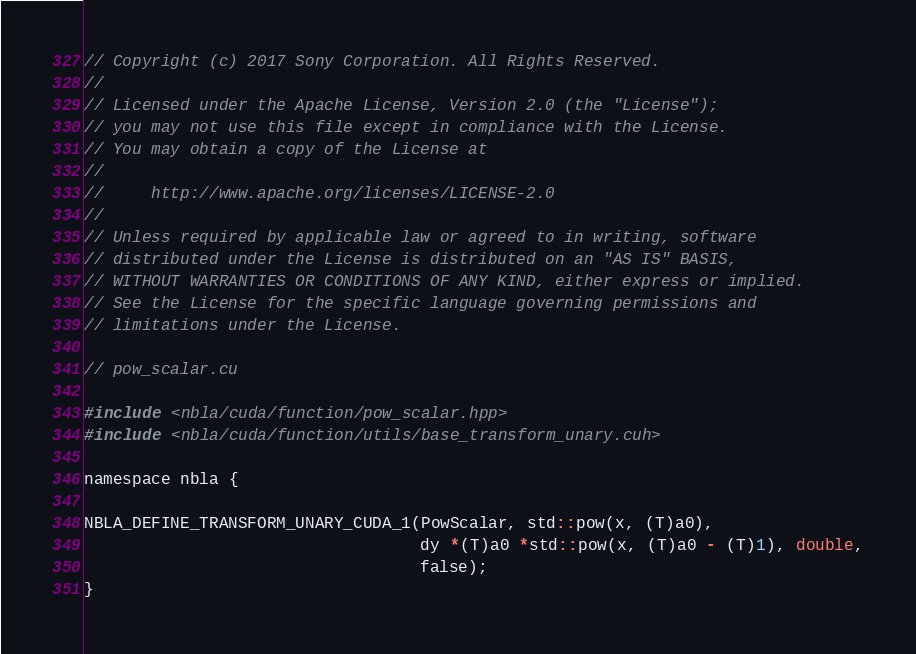<code> <loc_0><loc_0><loc_500><loc_500><_Cuda_>// Copyright (c) 2017 Sony Corporation. All Rights Reserved.
//
// Licensed under the Apache License, Version 2.0 (the "License");
// you may not use this file except in compliance with the License.
// You may obtain a copy of the License at
//
//     http://www.apache.org/licenses/LICENSE-2.0
//
// Unless required by applicable law or agreed to in writing, software
// distributed under the License is distributed on an "AS IS" BASIS,
// WITHOUT WARRANTIES OR CONDITIONS OF ANY KIND, either express or implied.
// See the License for the specific language governing permissions and
// limitations under the License.

// pow_scalar.cu

#include <nbla/cuda/function/pow_scalar.hpp>
#include <nbla/cuda/function/utils/base_transform_unary.cuh>

namespace nbla {

NBLA_DEFINE_TRANSFORM_UNARY_CUDA_1(PowScalar, std::pow(x, (T)a0),
                                   dy *(T)a0 *std::pow(x, (T)a0 - (T)1), double,
                                   false);
}
</code> 